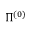<formula> <loc_0><loc_0><loc_500><loc_500>\Pi ^ { ( 0 ) }</formula> 